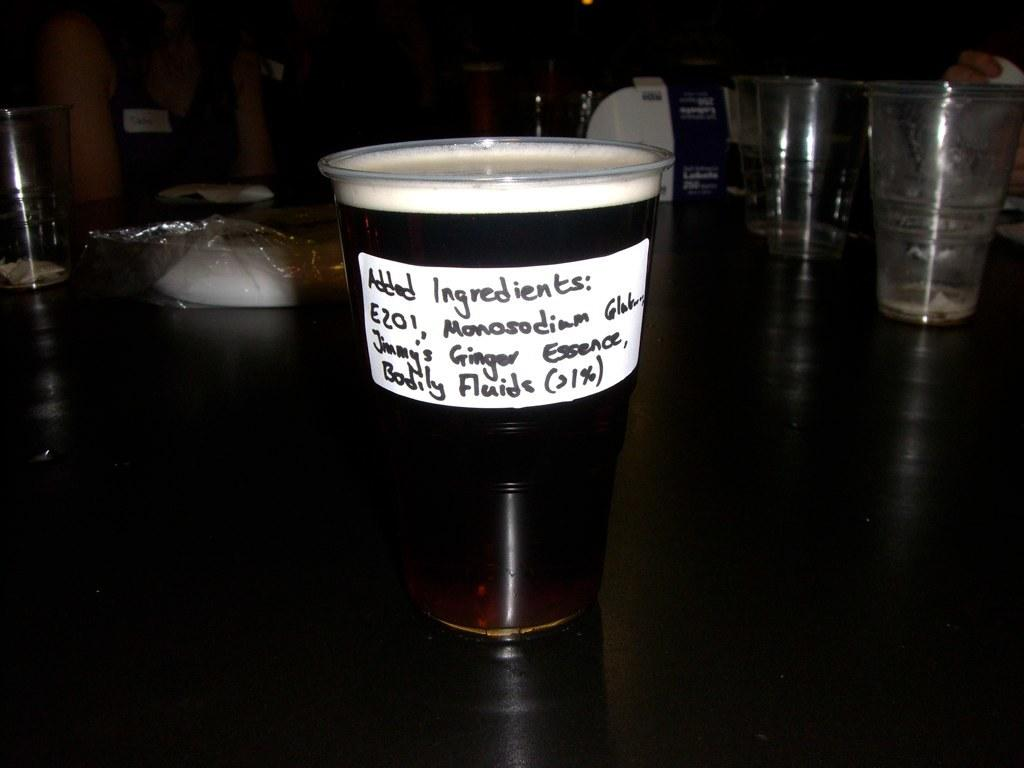<image>
Write a terse but informative summary of the picture. A glass sitting on the table called Jimmy's ginger essence. 